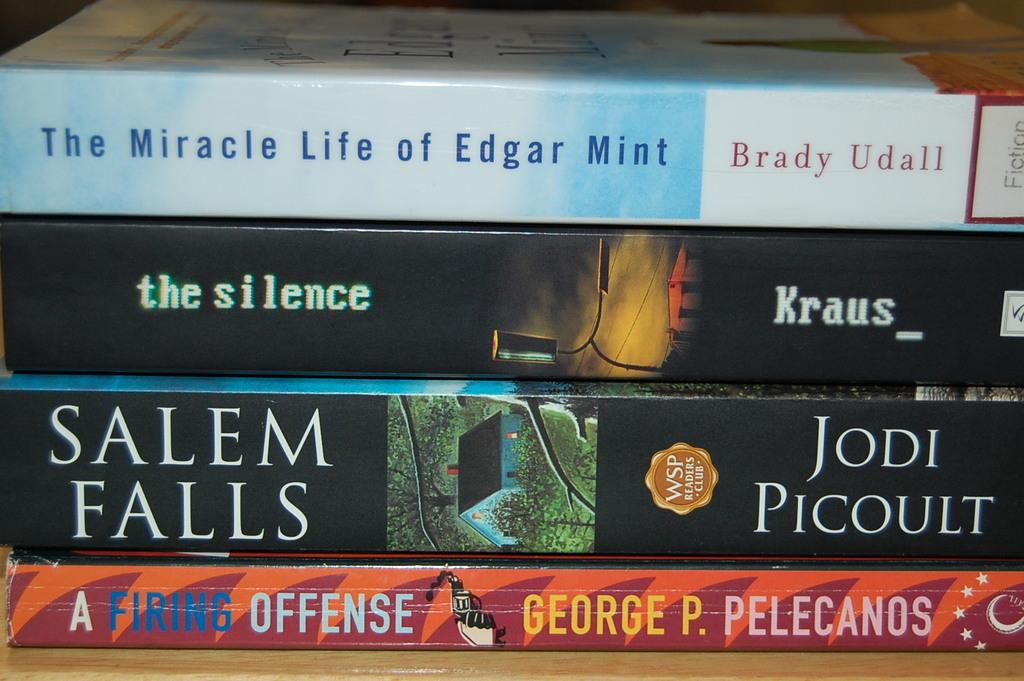<image>
Present a compact description of the photo's key features. A stack of books including one called The Miracle Life of Edgar Mint by Brady Udall. 